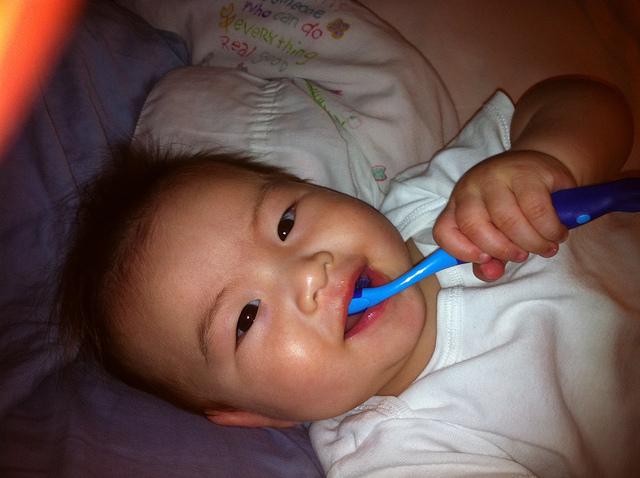What is the ethnicity of the baby?
Short answer required. Asian. Is the baby brushing its teeth?
Keep it brief. Yes. What color is the toothbrush?
Give a very brief answer. Blue. 